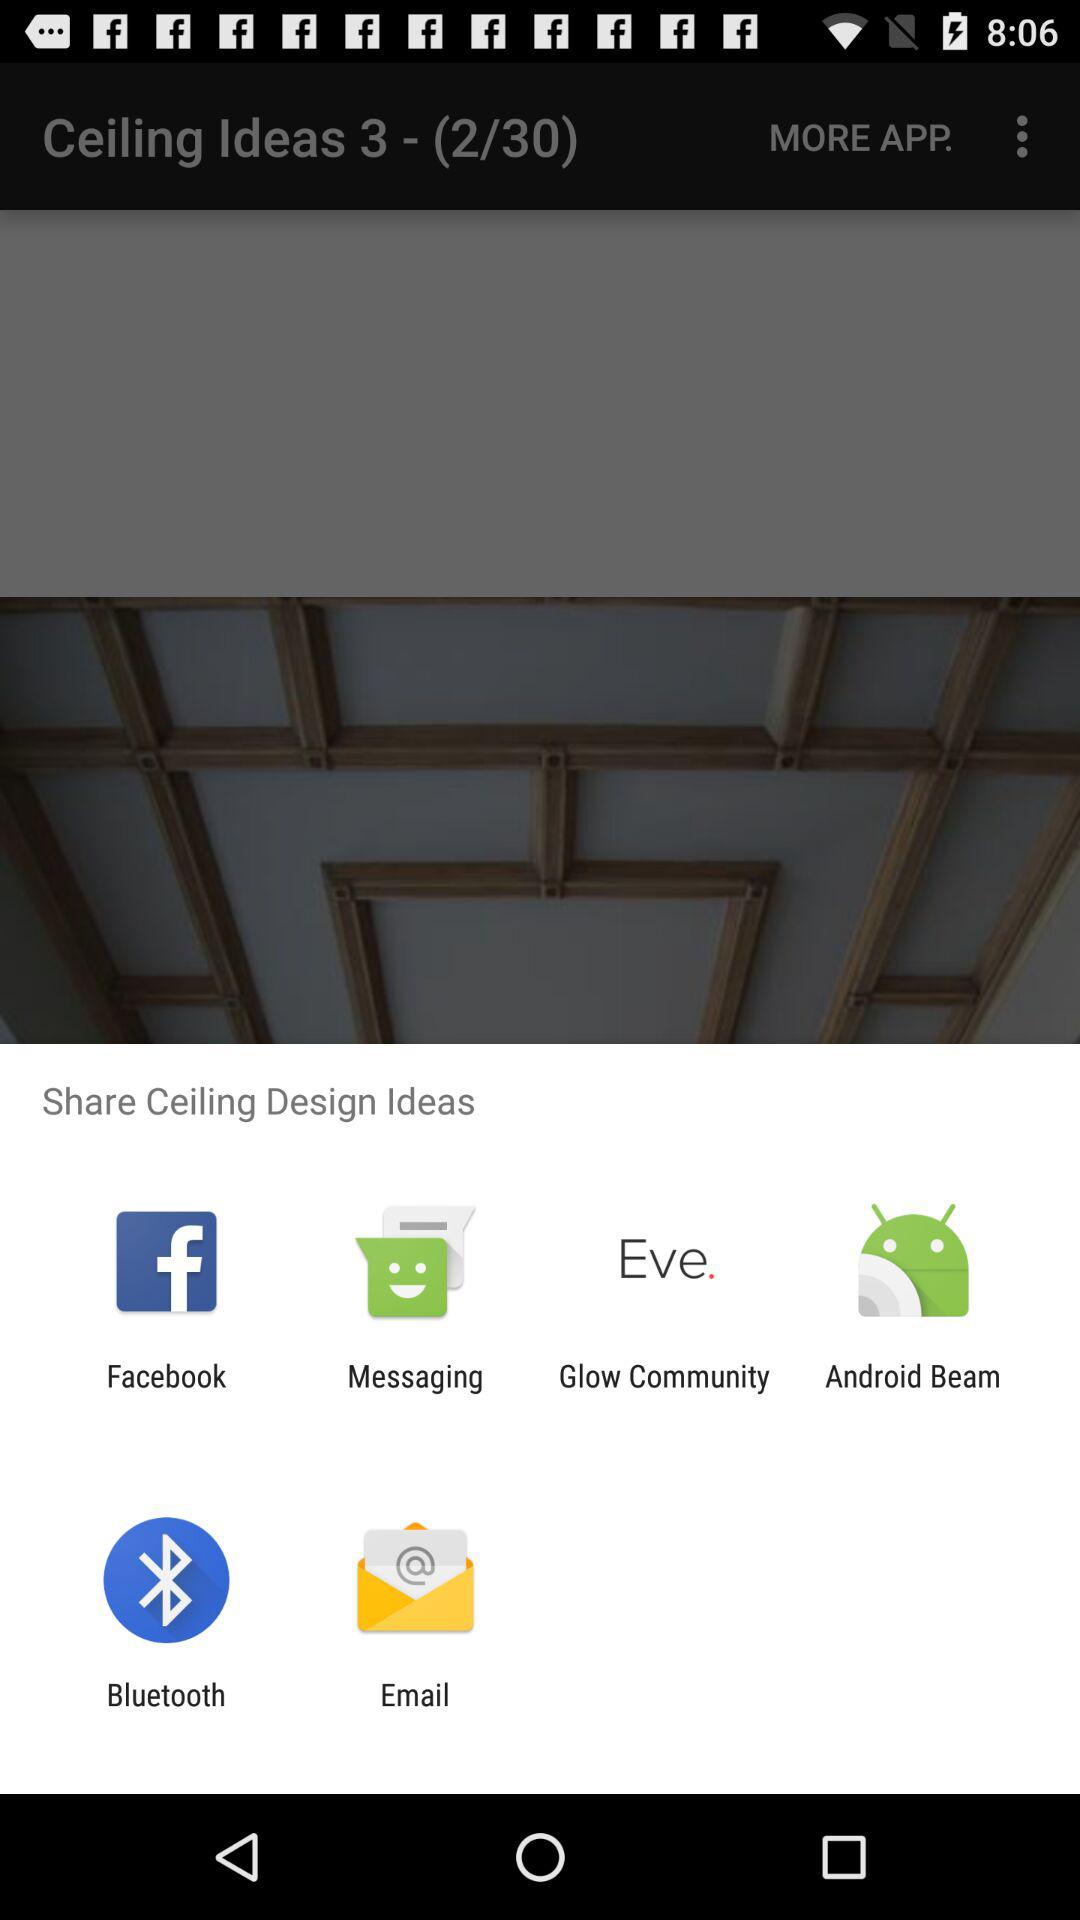Which are the different sharing options? The different sharing options are "Facebook", "Messaging", "Glow Community", "Android Beam", "Bluetooth" and "Email". 